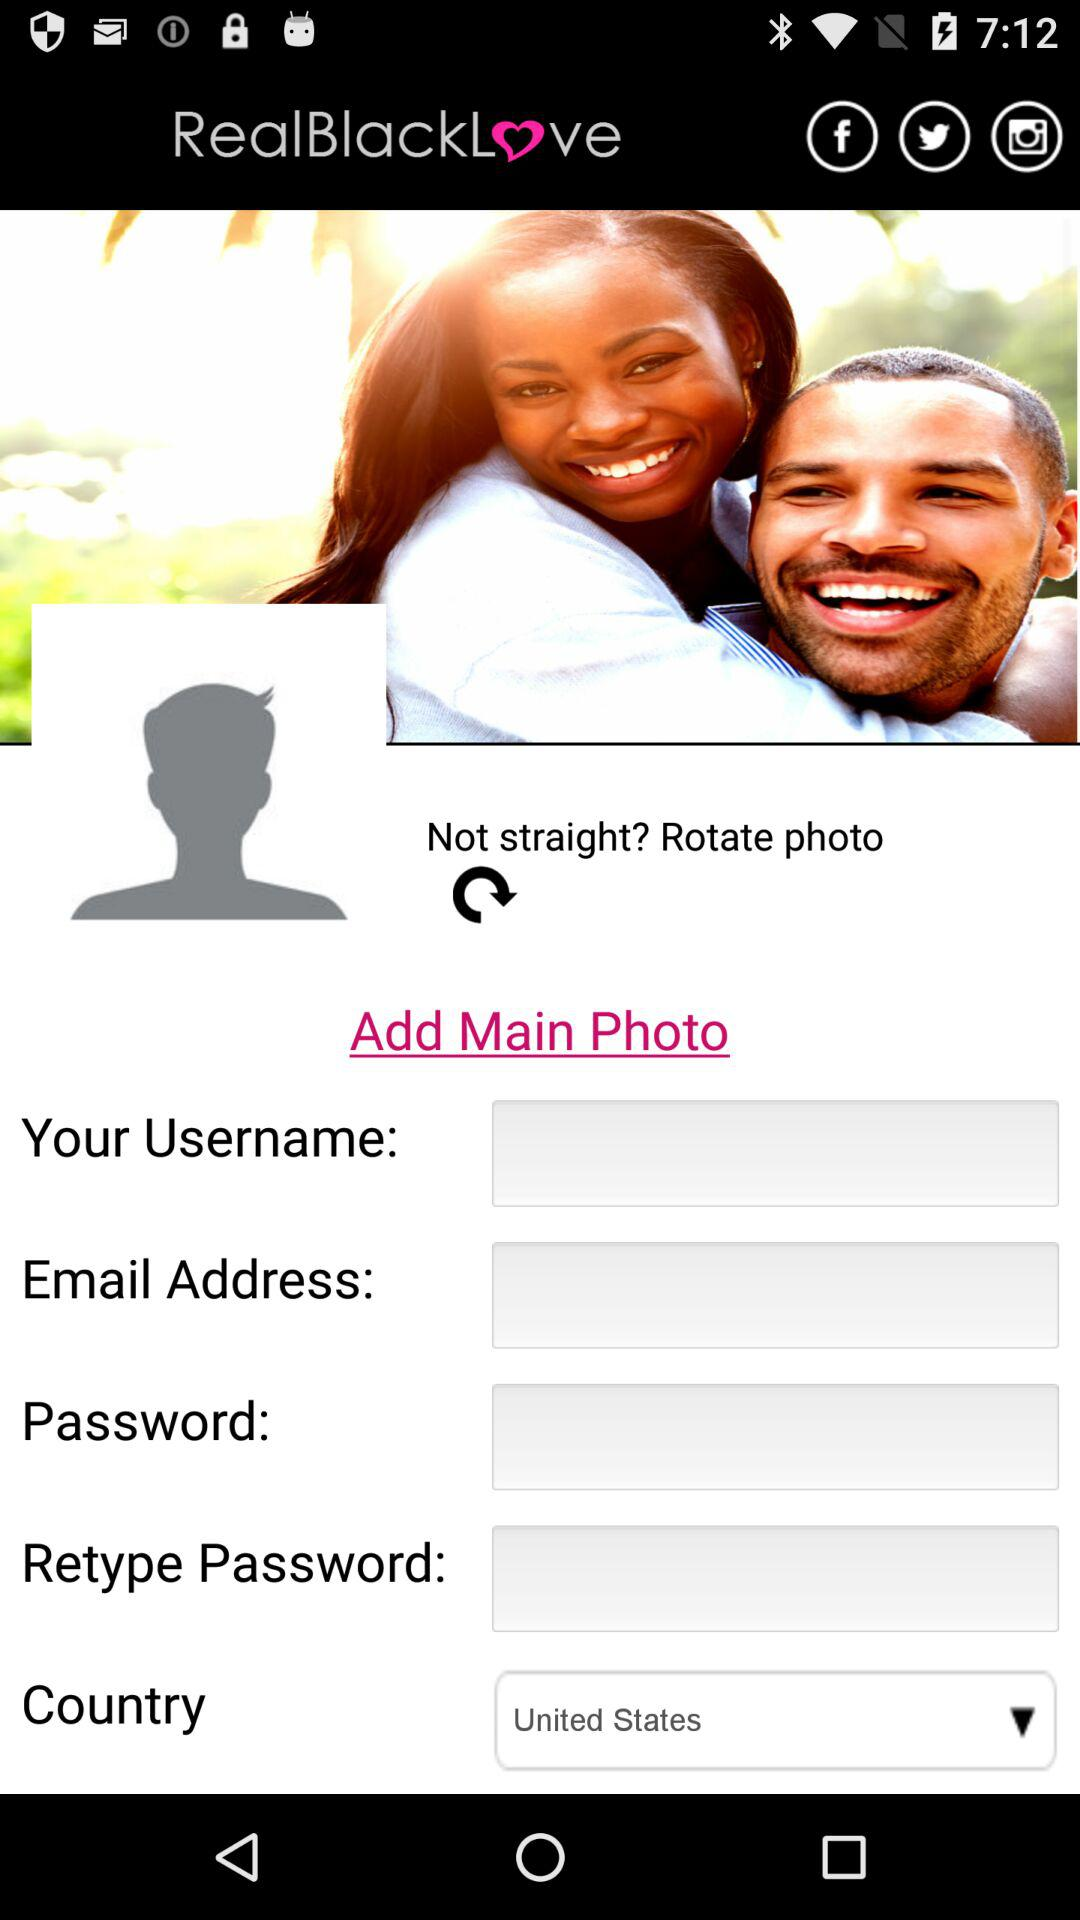What is the name of the application? The name of the application is "RealBlackLove". 